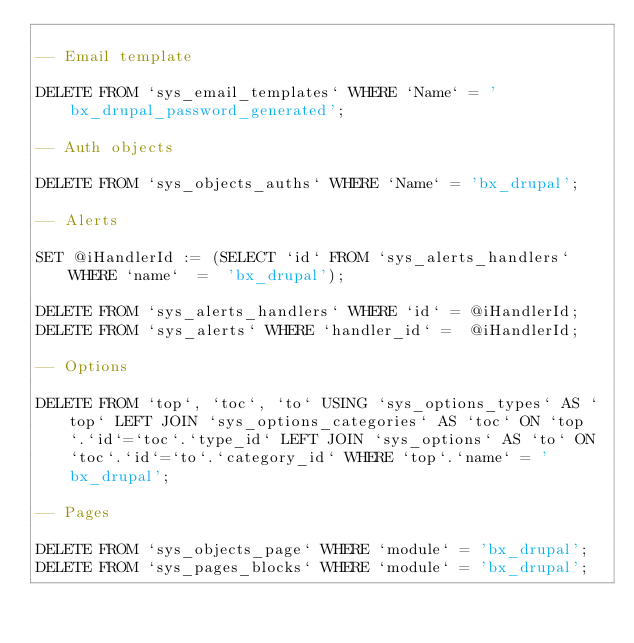<code> <loc_0><loc_0><loc_500><loc_500><_SQL_>
-- Email template

DELETE FROM `sys_email_templates` WHERE `Name` = 'bx_drupal_password_generated';

-- Auth objects

DELETE FROM `sys_objects_auths` WHERE `Name` = 'bx_drupal';

-- Alerts

SET @iHandlerId := (SELECT `id` FROM `sys_alerts_handlers`  WHERE `name`  =  'bx_drupal');

DELETE FROM `sys_alerts_handlers` WHERE `id` = @iHandlerId;
DELETE FROM `sys_alerts` WHERE `handler_id` =  @iHandlerId;

-- Options

DELETE FROM `top`, `toc`, `to` USING `sys_options_types` AS `top` LEFT JOIN `sys_options_categories` AS `toc` ON `top`.`id`=`toc`.`type_id` LEFT JOIN `sys_options` AS `to` ON `toc`.`id`=`to`.`category_id` WHERE `top`.`name` = 'bx_drupal';

-- Pages

DELETE FROM `sys_objects_page` WHERE `module` = 'bx_drupal';
DELETE FROM `sys_pages_blocks` WHERE `module` = 'bx_drupal';

</code> 